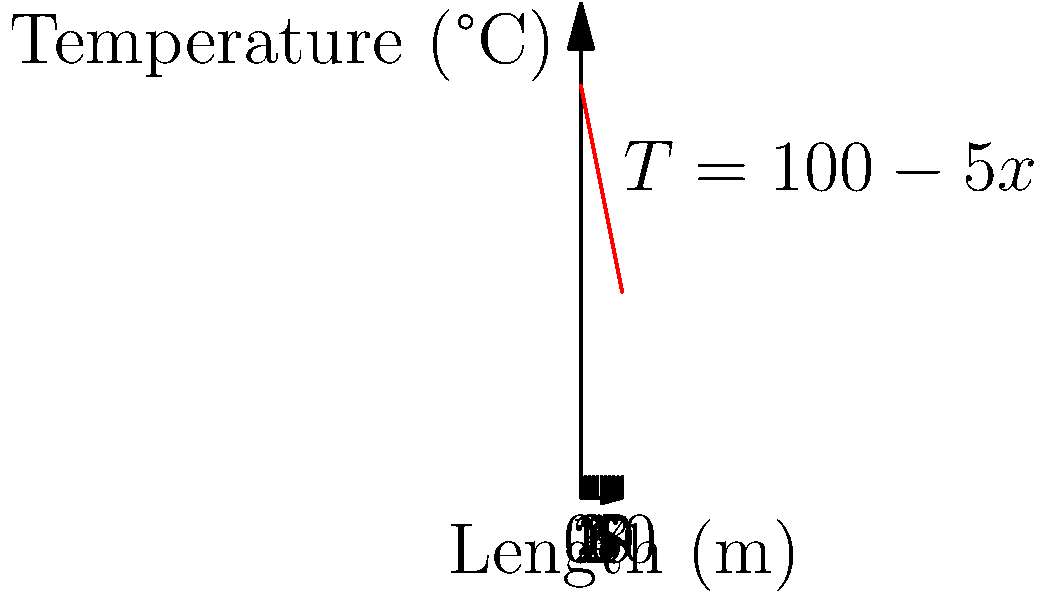As a biological illustrator, you often need to consider the effects of temperature on your specimens. Consider a cylindrical metal rod used in your illustration equipment, with a length of 10 meters and a linear temperature gradient along its length. The temperature at one end is 100°C and decreases linearly to 50°C at the other end. If the coefficient of thermal expansion for the metal is $1.2 \times 10^{-5}$ /°C, calculate the total elongation of the rod. Assume the initial temperature of the rod was 20°C. To solve this problem, we'll follow these steps:

1) First, we need to determine the temperature distribution along the rod. Given the information, we can express it as:
   $T(x) = 100 - 5x$, where $x$ is the distance from the hotter end in meters.

2) The elongation of a small segment $dx$ at position $x$ is given by:
   $d\Delta L = \alpha [T(x) - T_0] dx$
   where $\alpha$ is the coefficient of thermal expansion and $T_0$ is the initial temperature.

3) To find the total elongation, we need to integrate this over the entire length:
   $$\Delta L = \int_0^{10} \alpha [T(x) - T_0] dx$$

4) Substituting the temperature function and the given values:
   $$\Delta L = \int_0^{10} 1.2 \times 10^{-5} [(100 - 5x) - 20] dx$$

5) Simplifying:
   $$\Delta L = 1.2 \times 10^{-5} \int_0^{10} (80 - 5x) dx$$

6) Integrating:
   $$\Delta L = 1.2 \times 10^{-5} [80x - \frac{5}{2}x^2]_0^{10}$$

7) Evaluating the integral:
   $$\Delta L = 1.2 \times 10^{-5} [(800 - 250) - (0 - 0)]$$
   $$\Delta L = 1.2 \times 10^{-5} \times 550$$

8) Calculate the final result:
   $$\Delta L = 0.0066 \text{ meters} = 6.6 \text{ mm}$$
Answer: 6.6 mm 